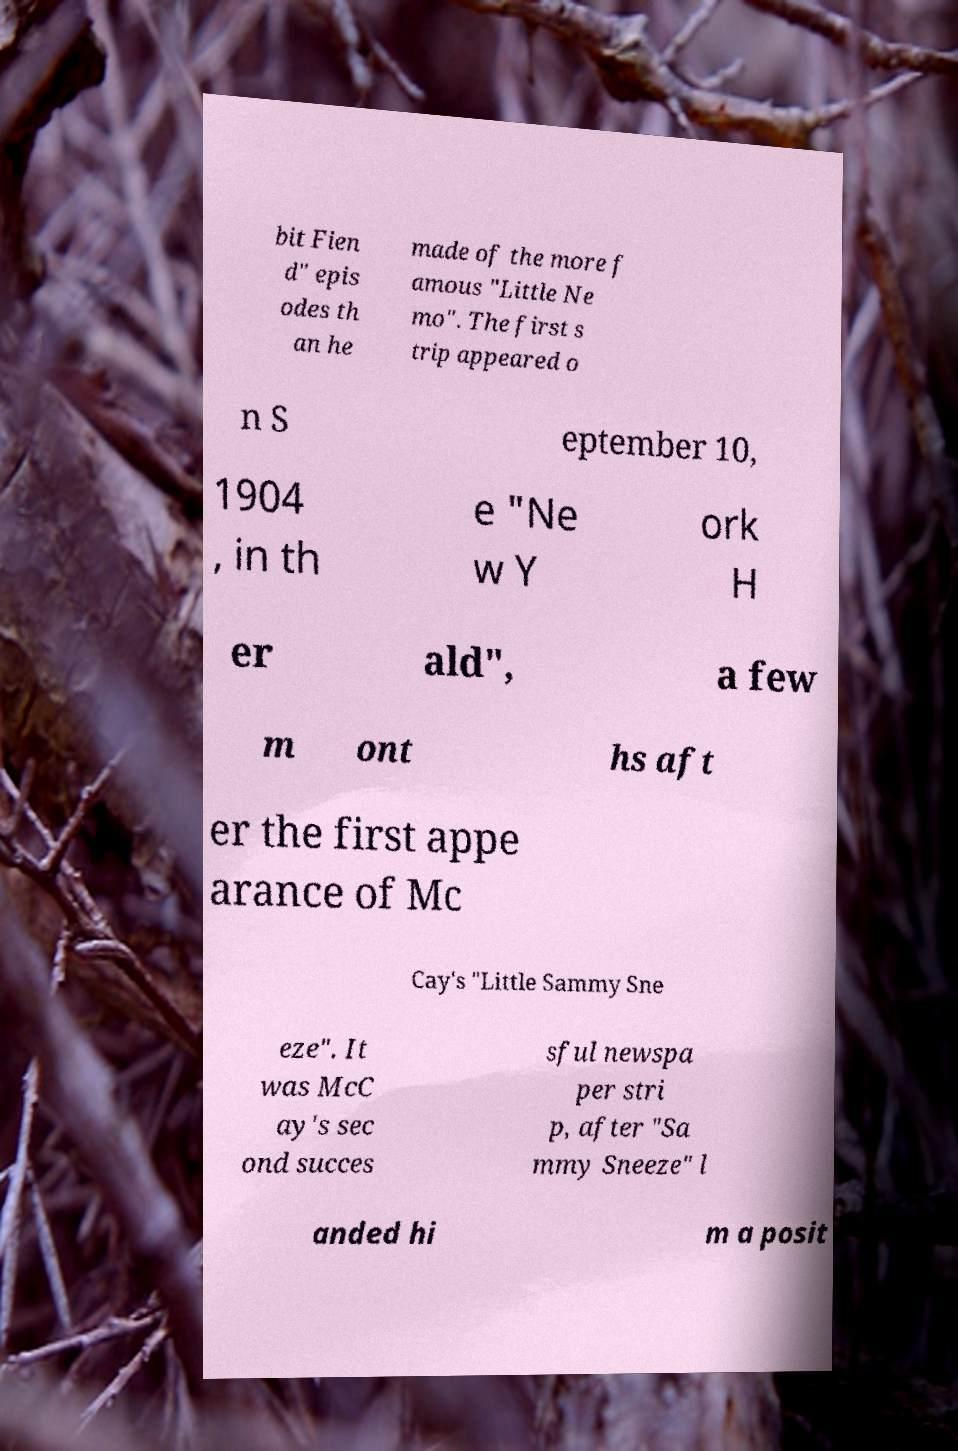Could you assist in decoding the text presented in this image and type it out clearly? bit Fien d" epis odes th an he made of the more f amous "Little Ne mo". The first s trip appeared o n S eptember 10, 1904 , in th e "Ne w Y ork H er ald", a few m ont hs aft er the first appe arance of Mc Cay's "Little Sammy Sne eze". It was McC ay's sec ond succes sful newspa per stri p, after "Sa mmy Sneeze" l anded hi m a posit 